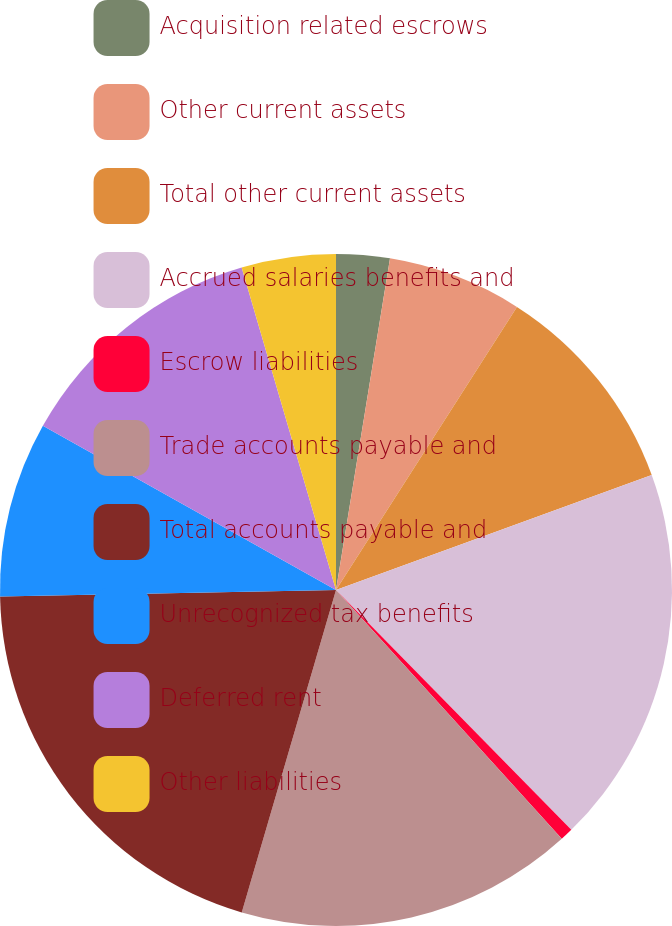Convert chart. <chart><loc_0><loc_0><loc_500><loc_500><pie_chart><fcel>Acquisition related escrows<fcel>Other current assets<fcel>Total other current assets<fcel>Accrued salaries benefits and<fcel>Escrow liabilities<fcel>Trade accounts payable and<fcel>Total accounts payable and<fcel>Unrecognized tax benefits<fcel>Deferred rent<fcel>Other liabilities<nl><fcel>2.57%<fcel>6.48%<fcel>10.39%<fcel>18.21%<fcel>0.62%<fcel>16.25%<fcel>20.16%<fcel>8.44%<fcel>12.34%<fcel>4.53%<nl></chart> 